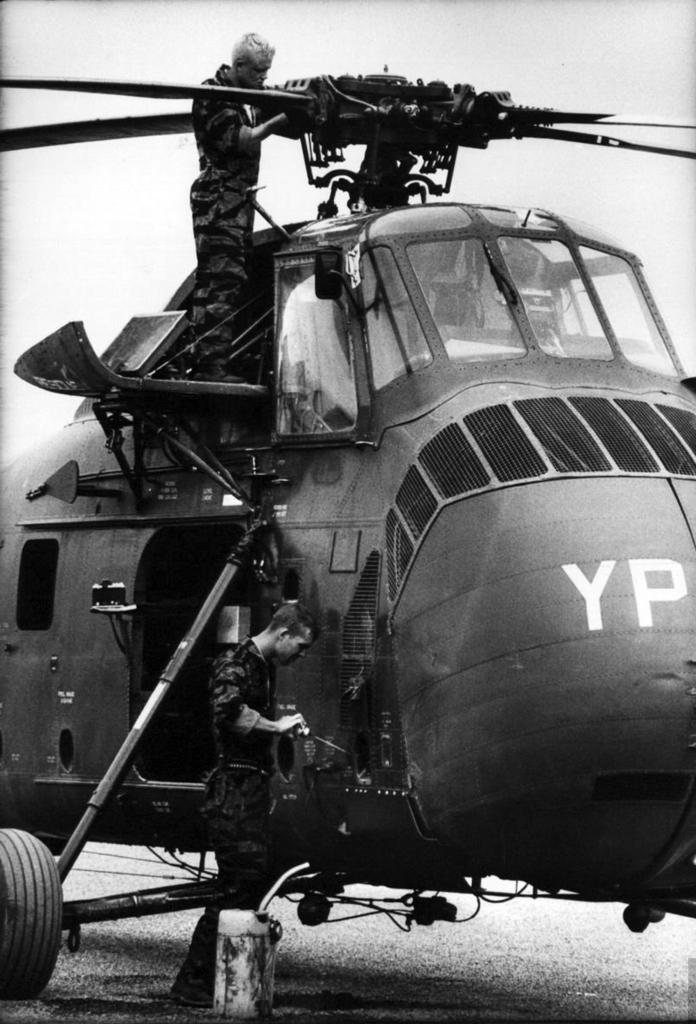<image>
Present a compact description of the photo's key features. Two identifying letters of the helicopter are YP. 